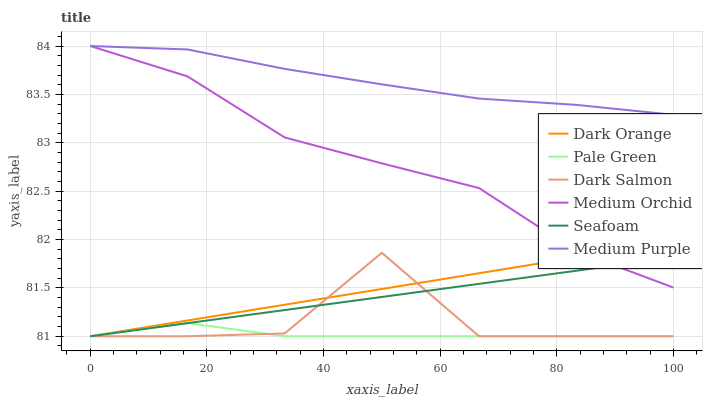Does Pale Green have the minimum area under the curve?
Answer yes or no. Yes. Does Medium Purple have the maximum area under the curve?
Answer yes or no. Yes. Does Medium Orchid have the minimum area under the curve?
Answer yes or no. No. Does Medium Orchid have the maximum area under the curve?
Answer yes or no. No. Is Seafoam the smoothest?
Answer yes or no. Yes. Is Dark Salmon the roughest?
Answer yes or no. Yes. Is Medium Orchid the smoothest?
Answer yes or no. No. Is Medium Orchid the roughest?
Answer yes or no. No. Does Dark Orange have the lowest value?
Answer yes or no. Yes. Does Medium Orchid have the lowest value?
Answer yes or no. No. Does Medium Purple have the highest value?
Answer yes or no. Yes. Does Dark Salmon have the highest value?
Answer yes or no. No. Is Dark Salmon less than Medium Purple?
Answer yes or no. Yes. Is Medium Orchid greater than Pale Green?
Answer yes or no. Yes. Does Dark Salmon intersect Seafoam?
Answer yes or no. Yes. Is Dark Salmon less than Seafoam?
Answer yes or no. No. Is Dark Salmon greater than Seafoam?
Answer yes or no. No. Does Dark Salmon intersect Medium Purple?
Answer yes or no. No. 